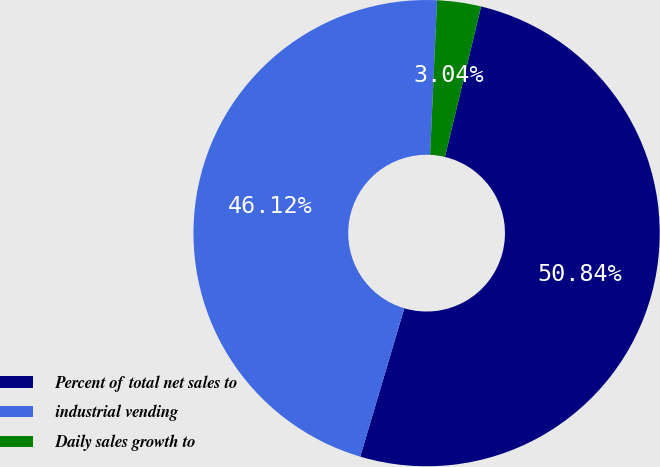Convert chart. <chart><loc_0><loc_0><loc_500><loc_500><pie_chart><fcel>Percent of total net sales to<fcel>industrial vending<fcel>Daily sales growth to<nl><fcel>50.84%<fcel>46.12%<fcel>3.04%<nl></chart> 